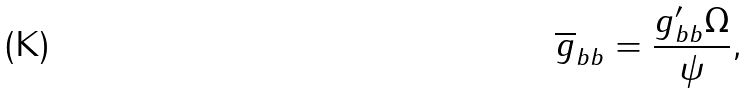Convert formula to latex. <formula><loc_0><loc_0><loc_500><loc_500>\overline { g } _ { b b } = \frac { g ^ { \prime } _ { b b } \Omega } { \psi } ,</formula> 